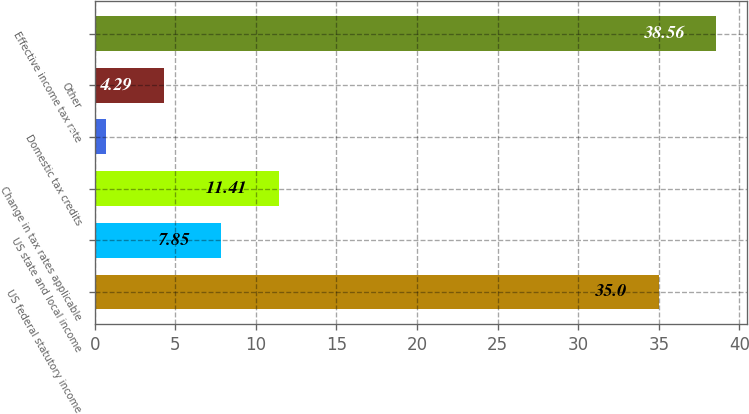Convert chart. <chart><loc_0><loc_0><loc_500><loc_500><bar_chart><fcel>US federal statutory income<fcel>US state and local income<fcel>Change in tax rates applicable<fcel>Domestic tax credits<fcel>Other<fcel>Effective income tax rate<nl><fcel>35<fcel>7.85<fcel>11.41<fcel>0.73<fcel>4.29<fcel>38.56<nl></chart> 